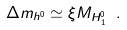<formula> <loc_0><loc_0><loc_500><loc_500>\Delta m _ { h ^ { 0 } } \simeq \xi M _ { H _ { 1 } ^ { 0 } } \ .</formula> 